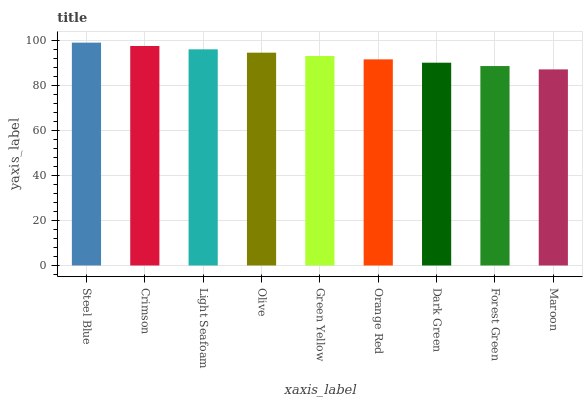Is Maroon the minimum?
Answer yes or no. Yes. Is Steel Blue the maximum?
Answer yes or no. Yes. Is Crimson the minimum?
Answer yes or no. No. Is Crimson the maximum?
Answer yes or no. No. Is Steel Blue greater than Crimson?
Answer yes or no. Yes. Is Crimson less than Steel Blue?
Answer yes or no. Yes. Is Crimson greater than Steel Blue?
Answer yes or no. No. Is Steel Blue less than Crimson?
Answer yes or no. No. Is Green Yellow the high median?
Answer yes or no. Yes. Is Green Yellow the low median?
Answer yes or no. Yes. Is Dark Green the high median?
Answer yes or no. No. Is Forest Green the low median?
Answer yes or no. No. 